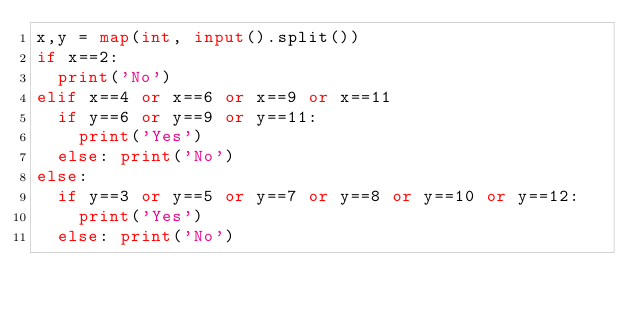Convert code to text. <code><loc_0><loc_0><loc_500><loc_500><_Python_>x,y = map(int, input().split())
if x==2:
  print('No')
elif x==4 or x==6 or x==9 or x==11
  if y==6 or y==9 or y==11:
    print('Yes')
  else: print('No')
else:
  if y==3 or y==5 or y==7 or y==8 or y==10 or y==12:
    print('Yes')
  else: print('No')</code> 